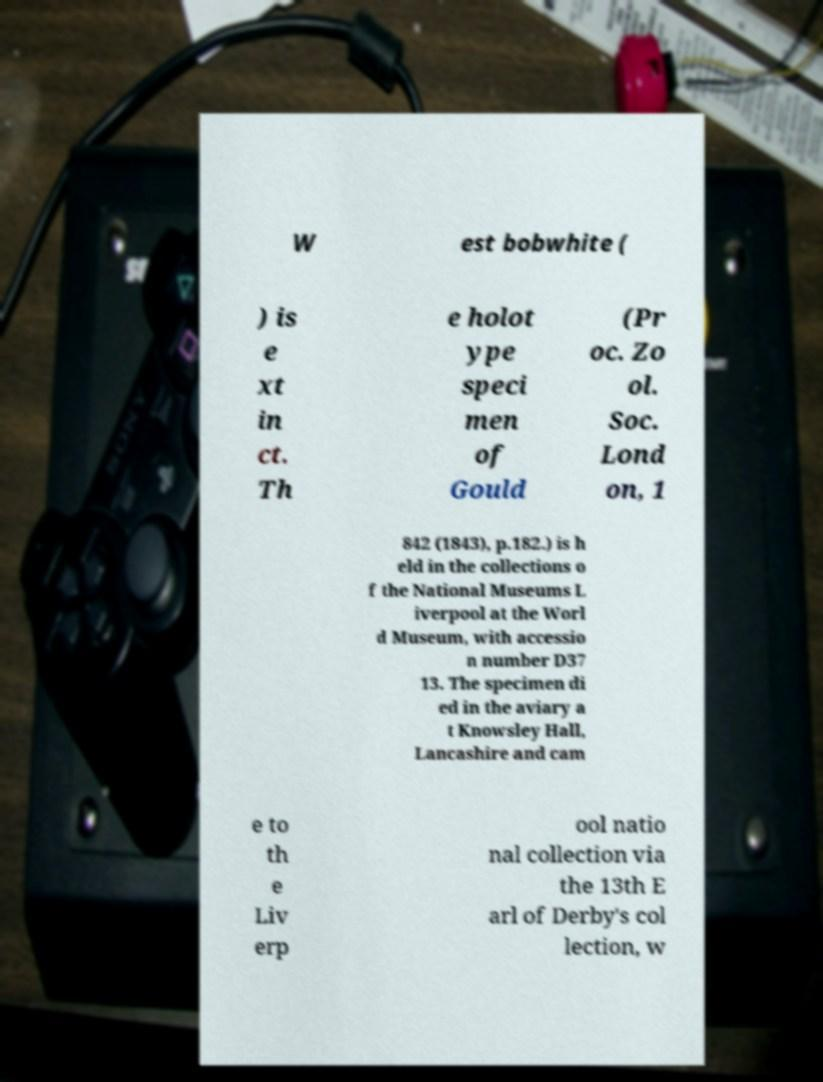There's text embedded in this image that I need extracted. Can you transcribe it verbatim? W est bobwhite ( ) is e xt in ct. Th e holot ype speci men of Gould (Pr oc. Zo ol. Soc. Lond on, 1 842 (1843), p.182.) is h eld in the collections o f the National Museums L iverpool at the Worl d Museum, with accessio n number D37 13. The specimen di ed in the aviary a t Knowsley Hall, Lancashire and cam e to th e Liv erp ool natio nal collection via the 13th E arl of Derby's col lection, w 